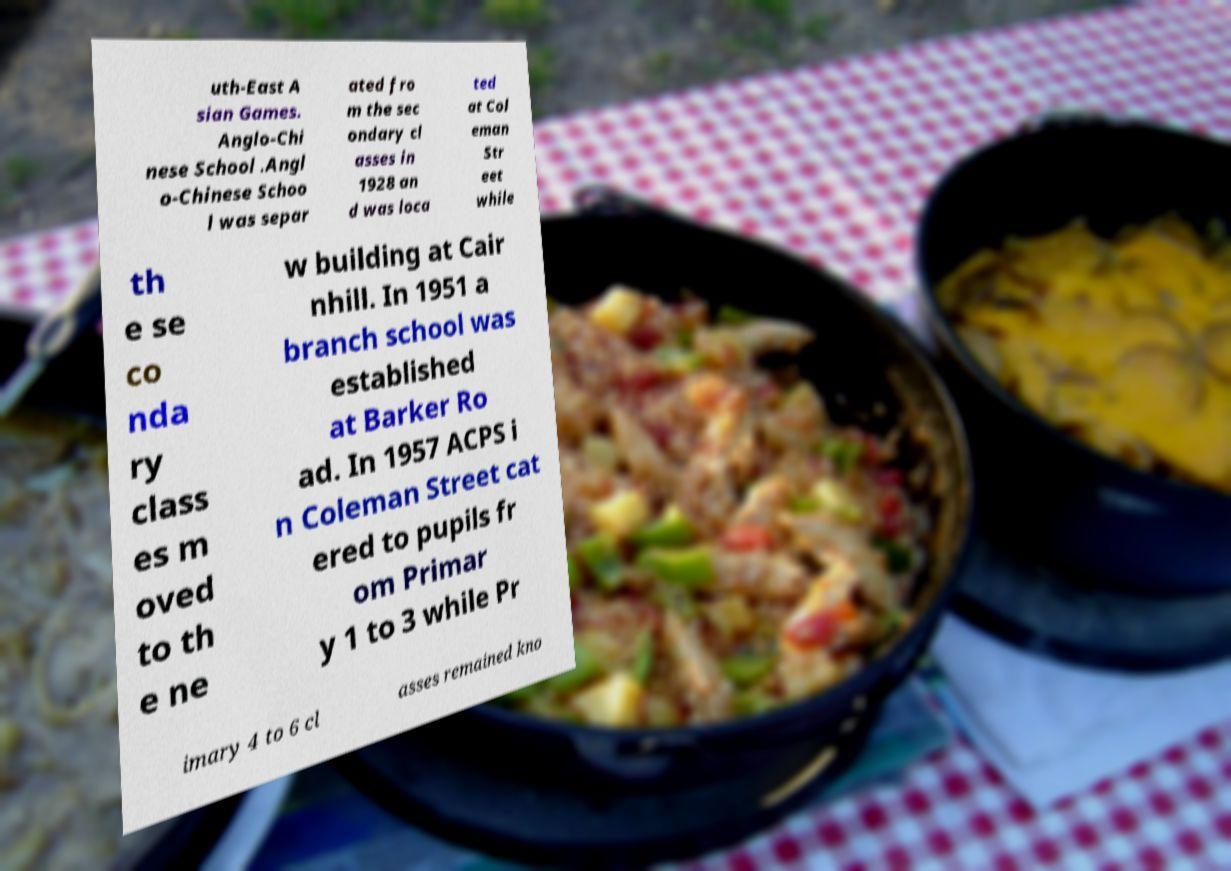I need the written content from this picture converted into text. Can you do that? uth-East A sian Games. Anglo-Chi nese School .Angl o-Chinese Schoo l was separ ated fro m the sec ondary cl asses in 1928 an d was loca ted at Col eman Str eet while th e se co nda ry class es m oved to th e ne w building at Cair nhill. In 1951 a branch school was established at Barker Ro ad. In 1957 ACPS i n Coleman Street cat ered to pupils fr om Primar y 1 to 3 while Pr imary 4 to 6 cl asses remained kno 